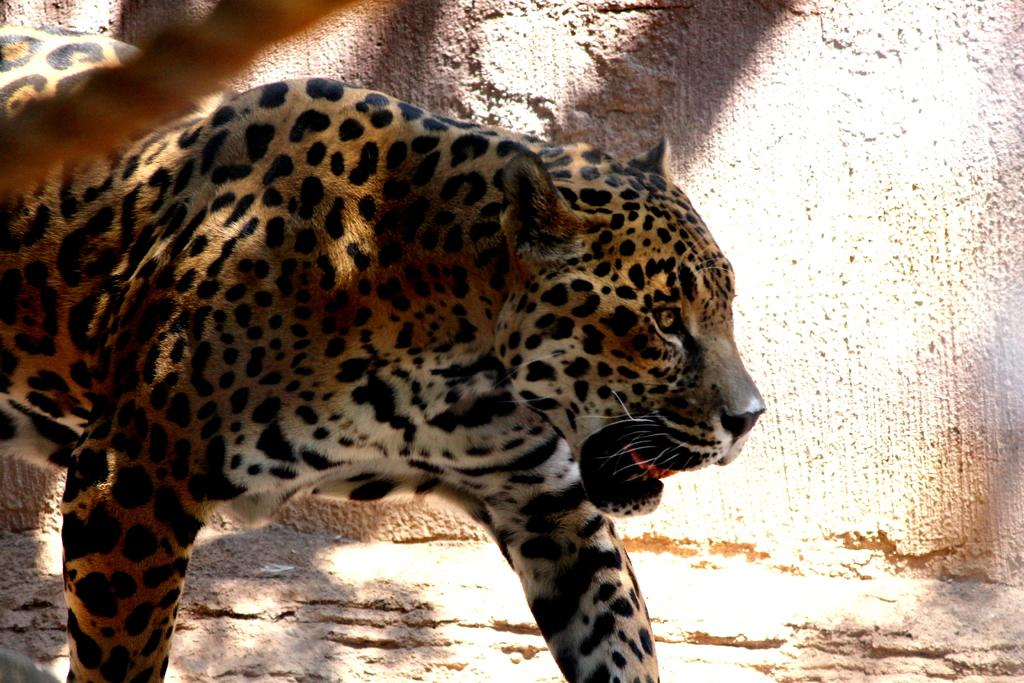Where was the image likely taken? The image was likely taken outside. What type of animal can be seen in the foreground of the image? There is an animal in the foreground of the image, which appears to be a leopard. What is the leopard doing in the image? The leopard is standing on the ground. What can be seen in the background of the image? There is a wall visible in the background of the image. What type of jelly is the leopard using to climb the wall in the image? There is no jelly present in the image, and the leopard is not climbing the wall. 